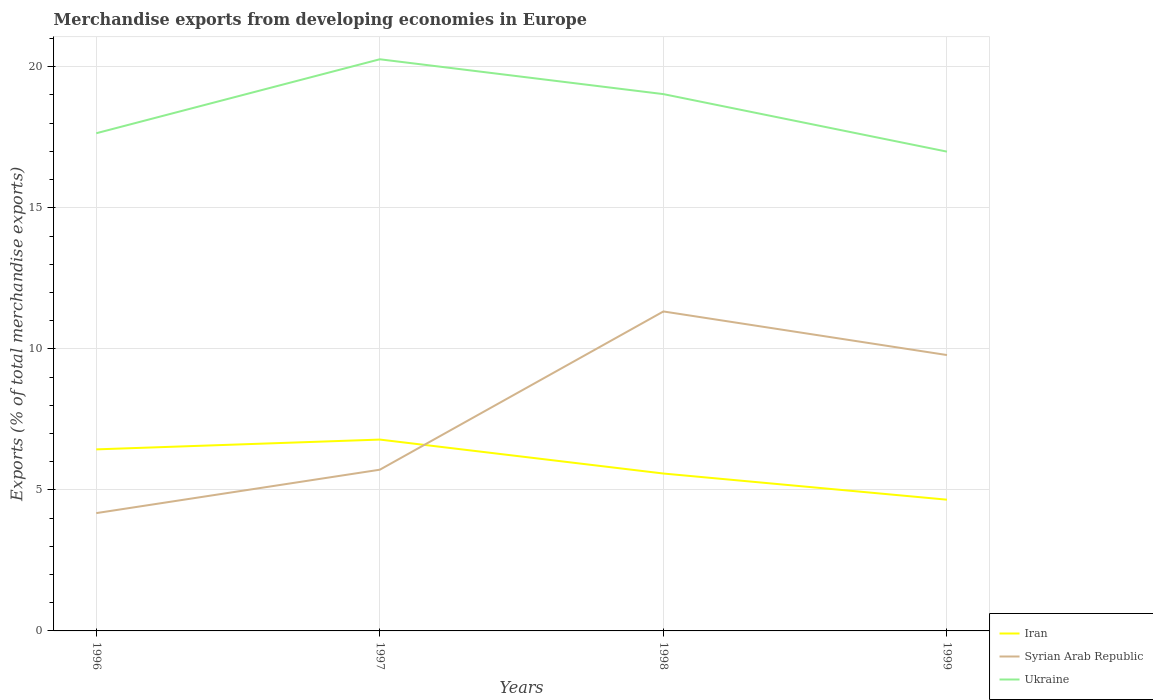Across all years, what is the maximum percentage of total merchandise exports in Syrian Arab Republic?
Provide a short and direct response. 4.18. What is the total percentage of total merchandise exports in Syrian Arab Republic in the graph?
Your response must be concise. -1.54. What is the difference between the highest and the second highest percentage of total merchandise exports in Ukraine?
Give a very brief answer. 3.27. How many lines are there?
Provide a short and direct response. 3. Does the graph contain any zero values?
Offer a very short reply. No. Where does the legend appear in the graph?
Give a very brief answer. Bottom right. What is the title of the graph?
Your response must be concise. Merchandise exports from developing economies in Europe. What is the label or title of the X-axis?
Your answer should be compact. Years. What is the label or title of the Y-axis?
Your answer should be compact. Exports (% of total merchandise exports). What is the Exports (% of total merchandise exports) in Iran in 1996?
Your answer should be compact. 6.44. What is the Exports (% of total merchandise exports) of Syrian Arab Republic in 1996?
Provide a succinct answer. 4.18. What is the Exports (% of total merchandise exports) in Ukraine in 1996?
Keep it short and to the point. 17.64. What is the Exports (% of total merchandise exports) of Iran in 1997?
Provide a succinct answer. 6.78. What is the Exports (% of total merchandise exports) of Syrian Arab Republic in 1997?
Offer a very short reply. 5.72. What is the Exports (% of total merchandise exports) of Ukraine in 1997?
Provide a short and direct response. 20.27. What is the Exports (% of total merchandise exports) of Iran in 1998?
Offer a terse response. 5.58. What is the Exports (% of total merchandise exports) in Syrian Arab Republic in 1998?
Offer a terse response. 11.33. What is the Exports (% of total merchandise exports) of Ukraine in 1998?
Provide a short and direct response. 19.03. What is the Exports (% of total merchandise exports) of Iran in 1999?
Provide a succinct answer. 4.65. What is the Exports (% of total merchandise exports) in Syrian Arab Republic in 1999?
Your response must be concise. 9.78. What is the Exports (% of total merchandise exports) in Ukraine in 1999?
Provide a succinct answer. 16.99. Across all years, what is the maximum Exports (% of total merchandise exports) in Iran?
Provide a short and direct response. 6.78. Across all years, what is the maximum Exports (% of total merchandise exports) of Syrian Arab Republic?
Offer a terse response. 11.33. Across all years, what is the maximum Exports (% of total merchandise exports) in Ukraine?
Keep it short and to the point. 20.27. Across all years, what is the minimum Exports (% of total merchandise exports) in Iran?
Your answer should be very brief. 4.65. Across all years, what is the minimum Exports (% of total merchandise exports) of Syrian Arab Republic?
Your response must be concise. 4.18. Across all years, what is the minimum Exports (% of total merchandise exports) in Ukraine?
Offer a very short reply. 16.99. What is the total Exports (% of total merchandise exports) in Iran in the graph?
Provide a succinct answer. 23.45. What is the total Exports (% of total merchandise exports) in Syrian Arab Republic in the graph?
Provide a short and direct response. 31. What is the total Exports (% of total merchandise exports) in Ukraine in the graph?
Your response must be concise. 73.93. What is the difference between the Exports (% of total merchandise exports) of Iran in 1996 and that in 1997?
Offer a very short reply. -0.35. What is the difference between the Exports (% of total merchandise exports) in Syrian Arab Republic in 1996 and that in 1997?
Your answer should be compact. -1.54. What is the difference between the Exports (% of total merchandise exports) in Ukraine in 1996 and that in 1997?
Make the answer very short. -2.62. What is the difference between the Exports (% of total merchandise exports) in Iran in 1996 and that in 1998?
Make the answer very short. 0.86. What is the difference between the Exports (% of total merchandise exports) in Syrian Arab Republic in 1996 and that in 1998?
Provide a succinct answer. -7.15. What is the difference between the Exports (% of total merchandise exports) of Ukraine in 1996 and that in 1998?
Keep it short and to the point. -1.39. What is the difference between the Exports (% of total merchandise exports) of Iran in 1996 and that in 1999?
Your answer should be very brief. 1.78. What is the difference between the Exports (% of total merchandise exports) in Syrian Arab Republic in 1996 and that in 1999?
Keep it short and to the point. -5.6. What is the difference between the Exports (% of total merchandise exports) of Ukraine in 1996 and that in 1999?
Provide a succinct answer. 0.65. What is the difference between the Exports (% of total merchandise exports) of Iran in 1997 and that in 1998?
Your answer should be compact. 1.2. What is the difference between the Exports (% of total merchandise exports) in Syrian Arab Republic in 1997 and that in 1998?
Offer a terse response. -5.61. What is the difference between the Exports (% of total merchandise exports) of Ukraine in 1997 and that in 1998?
Your response must be concise. 1.24. What is the difference between the Exports (% of total merchandise exports) of Iran in 1997 and that in 1999?
Provide a short and direct response. 2.13. What is the difference between the Exports (% of total merchandise exports) of Syrian Arab Republic in 1997 and that in 1999?
Offer a terse response. -4.06. What is the difference between the Exports (% of total merchandise exports) of Ukraine in 1997 and that in 1999?
Provide a succinct answer. 3.27. What is the difference between the Exports (% of total merchandise exports) of Iran in 1998 and that in 1999?
Ensure brevity in your answer.  0.93. What is the difference between the Exports (% of total merchandise exports) in Syrian Arab Republic in 1998 and that in 1999?
Provide a succinct answer. 1.55. What is the difference between the Exports (% of total merchandise exports) in Ukraine in 1998 and that in 1999?
Provide a short and direct response. 2.04. What is the difference between the Exports (% of total merchandise exports) of Iran in 1996 and the Exports (% of total merchandise exports) of Syrian Arab Republic in 1997?
Provide a succinct answer. 0.72. What is the difference between the Exports (% of total merchandise exports) of Iran in 1996 and the Exports (% of total merchandise exports) of Ukraine in 1997?
Give a very brief answer. -13.83. What is the difference between the Exports (% of total merchandise exports) of Syrian Arab Republic in 1996 and the Exports (% of total merchandise exports) of Ukraine in 1997?
Give a very brief answer. -16.09. What is the difference between the Exports (% of total merchandise exports) in Iran in 1996 and the Exports (% of total merchandise exports) in Syrian Arab Republic in 1998?
Your answer should be very brief. -4.89. What is the difference between the Exports (% of total merchandise exports) in Iran in 1996 and the Exports (% of total merchandise exports) in Ukraine in 1998?
Your answer should be compact. -12.59. What is the difference between the Exports (% of total merchandise exports) of Syrian Arab Republic in 1996 and the Exports (% of total merchandise exports) of Ukraine in 1998?
Provide a succinct answer. -14.85. What is the difference between the Exports (% of total merchandise exports) in Iran in 1996 and the Exports (% of total merchandise exports) in Syrian Arab Republic in 1999?
Your answer should be very brief. -3.34. What is the difference between the Exports (% of total merchandise exports) of Iran in 1996 and the Exports (% of total merchandise exports) of Ukraine in 1999?
Offer a terse response. -10.56. What is the difference between the Exports (% of total merchandise exports) of Syrian Arab Republic in 1996 and the Exports (% of total merchandise exports) of Ukraine in 1999?
Make the answer very short. -12.82. What is the difference between the Exports (% of total merchandise exports) of Iran in 1997 and the Exports (% of total merchandise exports) of Syrian Arab Republic in 1998?
Offer a very short reply. -4.54. What is the difference between the Exports (% of total merchandise exports) in Iran in 1997 and the Exports (% of total merchandise exports) in Ukraine in 1998?
Your response must be concise. -12.25. What is the difference between the Exports (% of total merchandise exports) of Syrian Arab Republic in 1997 and the Exports (% of total merchandise exports) of Ukraine in 1998?
Provide a short and direct response. -13.32. What is the difference between the Exports (% of total merchandise exports) in Iran in 1997 and the Exports (% of total merchandise exports) in Syrian Arab Republic in 1999?
Offer a very short reply. -3. What is the difference between the Exports (% of total merchandise exports) of Iran in 1997 and the Exports (% of total merchandise exports) of Ukraine in 1999?
Ensure brevity in your answer.  -10.21. What is the difference between the Exports (% of total merchandise exports) in Syrian Arab Republic in 1997 and the Exports (% of total merchandise exports) in Ukraine in 1999?
Your response must be concise. -11.28. What is the difference between the Exports (% of total merchandise exports) in Iran in 1998 and the Exports (% of total merchandise exports) in Syrian Arab Republic in 1999?
Keep it short and to the point. -4.2. What is the difference between the Exports (% of total merchandise exports) in Iran in 1998 and the Exports (% of total merchandise exports) in Ukraine in 1999?
Your answer should be compact. -11.41. What is the difference between the Exports (% of total merchandise exports) in Syrian Arab Republic in 1998 and the Exports (% of total merchandise exports) in Ukraine in 1999?
Make the answer very short. -5.67. What is the average Exports (% of total merchandise exports) of Iran per year?
Keep it short and to the point. 5.86. What is the average Exports (% of total merchandise exports) in Syrian Arab Republic per year?
Provide a succinct answer. 7.75. What is the average Exports (% of total merchandise exports) in Ukraine per year?
Offer a terse response. 18.48. In the year 1996, what is the difference between the Exports (% of total merchandise exports) in Iran and Exports (% of total merchandise exports) in Syrian Arab Republic?
Your answer should be very brief. 2.26. In the year 1996, what is the difference between the Exports (% of total merchandise exports) of Iran and Exports (% of total merchandise exports) of Ukraine?
Provide a short and direct response. -11.21. In the year 1996, what is the difference between the Exports (% of total merchandise exports) of Syrian Arab Republic and Exports (% of total merchandise exports) of Ukraine?
Give a very brief answer. -13.47. In the year 1997, what is the difference between the Exports (% of total merchandise exports) of Iran and Exports (% of total merchandise exports) of Syrian Arab Republic?
Your answer should be very brief. 1.07. In the year 1997, what is the difference between the Exports (% of total merchandise exports) in Iran and Exports (% of total merchandise exports) in Ukraine?
Ensure brevity in your answer.  -13.48. In the year 1997, what is the difference between the Exports (% of total merchandise exports) in Syrian Arab Republic and Exports (% of total merchandise exports) in Ukraine?
Keep it short and to the point. -14.55. In the year 1998, what is the difference between the Exports (% of total merchandise exports) in Iran and Exports (% of total merchandise exports) in Syrian Arab Republic?
Provide a short and direct response. -5.75. In the year 1998, what is the difference between the Exports (% of total merchandise exports) in Iran and Exports (% of total merchandise exports) in Ukraine?
Offer a very short reply. -13.45. In the year 1998, what is the difference between the Exports (% of total merchandise exports) in Syrian Arab Republic and Exports (% of total merchandise exports) in Ukraine?
Your answer should be compact. -7.71. In the year 1999, what is the difference between the Exports (% of total merchandise exports) of Iran and Exports (% of total merchandise exports) of Syrian Arab Republic?
Offer a terse response. -5.13. In the year 1999, what is the difference between the Exports (% of total merchandise exports) in Iran and Exports (% of total merchandise exports) in Ukraine?
Offer a terse response. -12.34. In the year 1999, what is the difference between the Exports (% of total merchandise exports) in Syrian Arab Republic and Exports (% of total merchandise exports) in Ukraine?
Offer a terse response. -7.21. What is the ratio of the Exports (% of total merchandise exports) of Iran in 1996 to that in 1997?
Your answer should be compact. 0.95. What is the ratio of the Exports (% of total merchandise exports) in Syrian Arab Republic in 1996 to that in 1997?
Offer a terse response. 0.73. What is the ratio of the Exports (% of total merchandise exports) of Ukraine in 1996 to that in 1997?
Give a very brief answer. 0.87. What is the ratio of the Exports (% of total merchandise exports) of Iran in 1996 to that in 1998?
Give a very brief answer. 1.15. What is the ratio of the Exports (% of total merchandise exports) of Syrian Arab Republic in 1996 to that in 1998?
Offer a very short reply. 0.37. What is the ratio of the Exports (% of total merchandise exports) in Ukraine in 1996 to that in 1998?
Provide a short and direct response. 0.93. What is the ratio of the Exports (% of total merchandise exports) of Iran in 1996 to that in 1999?
Your answer should be very brief. 1.38. What is the ratio of the Exports (% of total merchandise exports) in Syrian Arab Republic in 1996 to that in 1999?
Give a very brief answer. 0.43. What is the ratio of the Exports (% of total merchandise exports) in Ukraine in 1996 to that in 1999?
Provide a short and direct response. 1.04. What is the ratio of the Exports (% of total merchandise exports) in Iran in 1997 to that in 1998?
Your response must be concise. 1.22. What is the ratio of the Exports (% of total merchandise exports) of Syrian Arab Republic in 1997 to that in 1998?
Keep it short and to the point. 0.5. What is the ratio of the Exports (% of total merchandise exports) in Ukraine in 1997 to that in 1998?
Offer a terse response. 1.06. What is the ratio of the Exports (% of total merchandise exports) of Iran in 1997 to that in 1999?
Your response must be concise. 1.46. What is the ratio of the Exports (% of total merchandise exports) in Syrian Arab Republic in 1997 to that in 1999?
Your answer should be compact. 0.58. What is the ratio of the Exports (% of total merchandise exports) in Ukraine in 1997 to that in 1999?
Provide a succinct answer. 1.19. What is the ratio of the Exports (% of total merchandise exports) of Iran in 1998 to that in 1999?
Offer a terse response. 1.2. What is the ratio of the Exports (% of total merchandise exports) of Syrian Arab Republic in 1998 to that in 1999?
Your response must be concise. 1.16. What is the ratio of the Exports (% of total merchandise exports) of Ukraine in 1998 to that in 1999?
Make the answer very short. 1.12. What is the difference between the highest and the second highest Exports (% of total merchandise exports) in Iran?
Offer a terse response. 0.35. What is the difference between the highest and the second highest Exports (% of total merchandise exports) of Syrian Arab Republic?
Keep it short and to the point. 1.55. What is the difference between the highest and the second highest Exports (% of total merchandise exports) of Ukraine?
Provide a short and direct response. 1.24. What is the difference between the highest and the lowest Exports (% of total merchandise exports) of Iran?
Provide a succinct answer. 2.13. What is the difference between the highest and the lowest Exports (% of total merchandise exports) of Syrian Arab Republic?
Offer a very short reply. 7.15. What is the difference between the highest and the lowest Exports (% of total merchandise exports) of Ukraine?
Give a very brief answer. 3.27. 